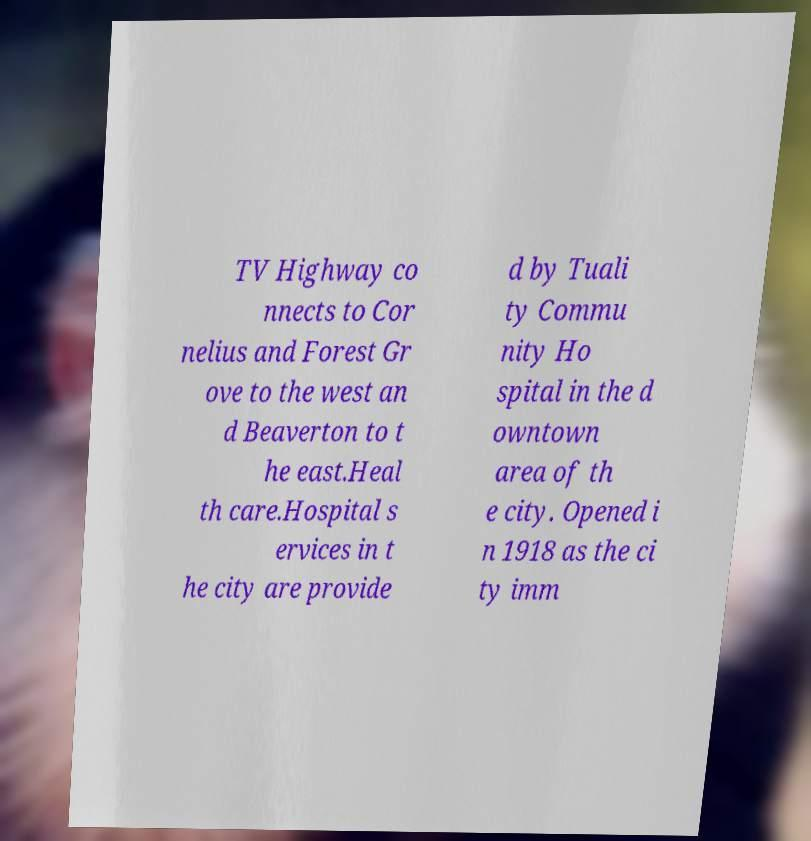I need the written content from this picture converted into text. Can you do that? TV Highway co nnects to Cor nelius and Forest Gr ove to the west an d Beaverton to t he east.Heal th care.Hospital s ervices in t he city are provide d by Tuali ty Commu nity Ho spital in the d owntown area of th e city. Opened i n 1918 as the ci ty imm 